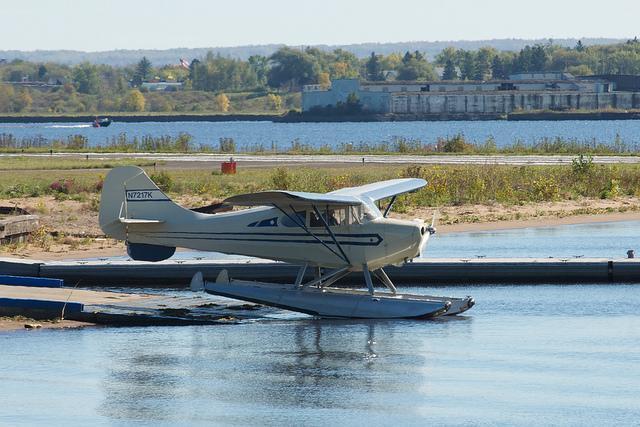How many planes are on the water?
Give a very brief answer. 1. 